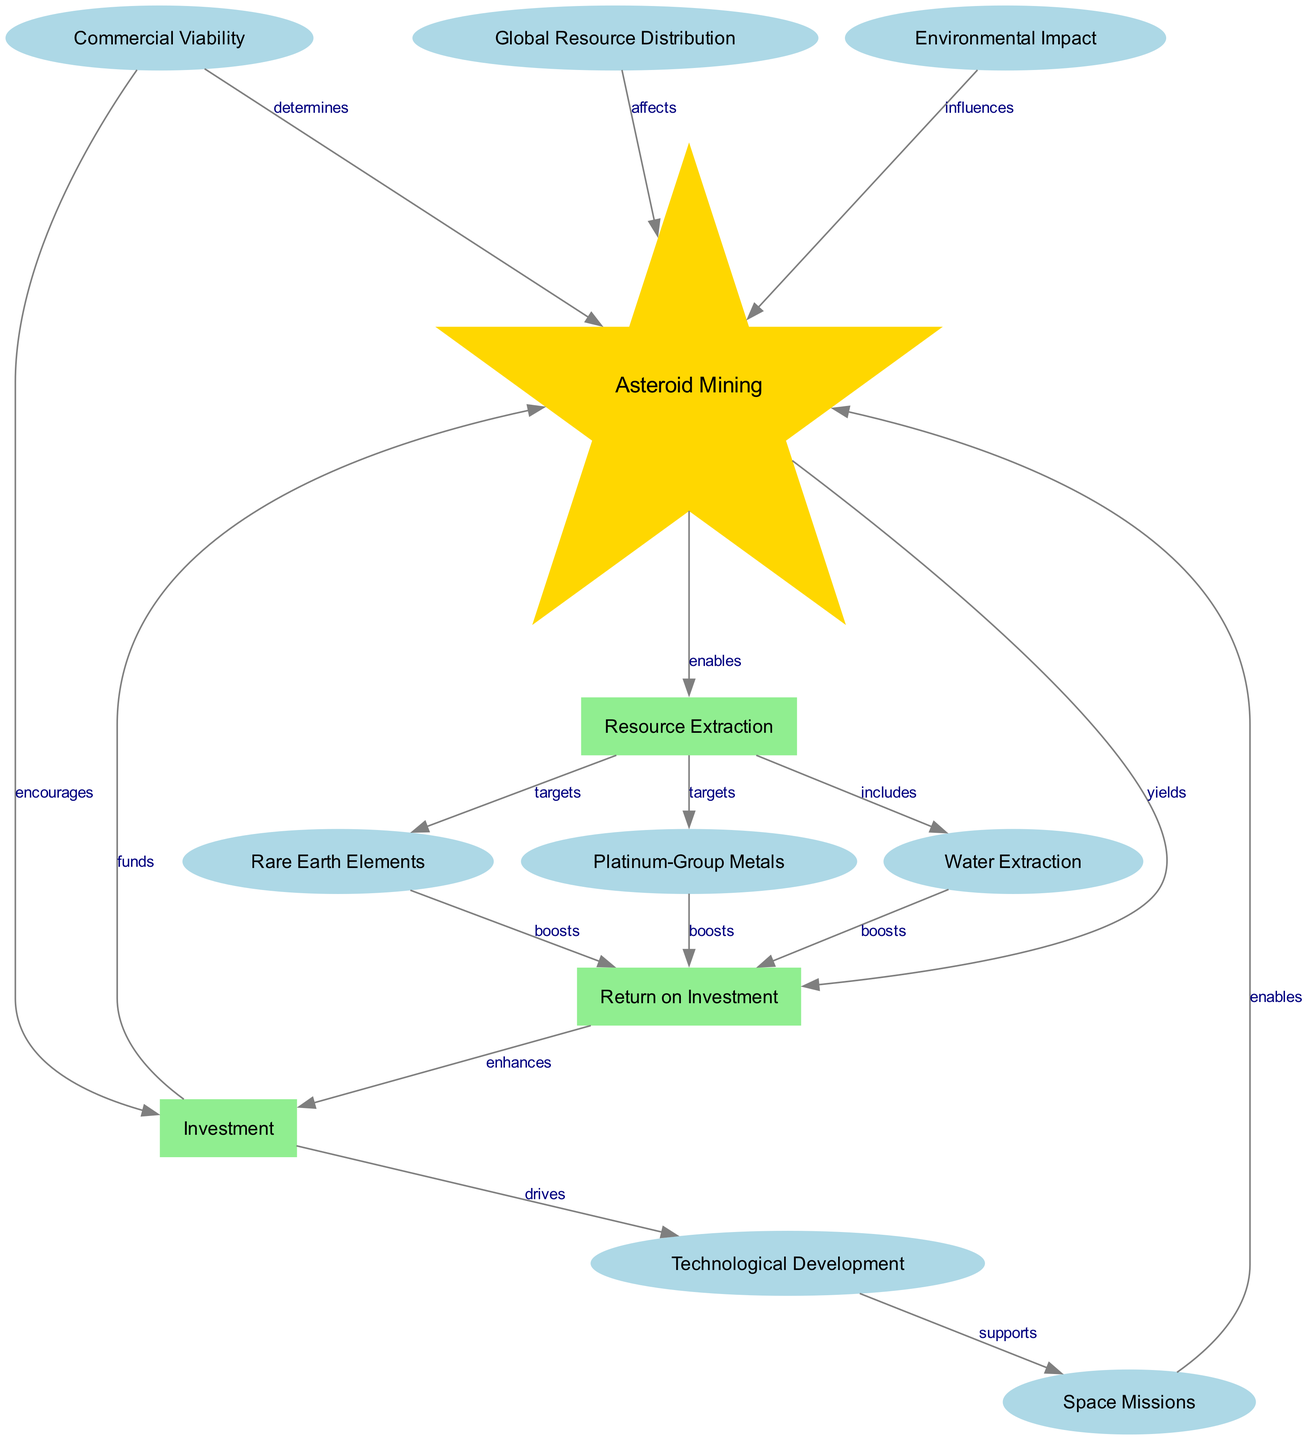What is the primary activity associated with node 1? Node 1 is labeled "Asteroid Mining," indicating that it is the central activity depicted in the diagram.
Answer: Asteroid Mining Which nodes are targeted for resource extraction? The edges from node 2 ("Resource Extraction") indicate that it targets "Platinum-Group Metals" and "Rare Earth Elements." This includes both nodes 3 and 5.
Answer: Platinum-Group Metals and Rare Earth Elements How many nodes are involved in the process of asteroid mining? The diagram contains a total of 12 nodes related to asteroid mining, including the primary node and all others, detailing various factors like resource extraction and investment.
Answer: 12 What type of relationship exists between "Investment" and "Asteroid Mining"? The edge from node 6 ("Investment") to node 1 ("Asteroid Mining") is labeled "funds," indicating a financial support relationship.
Answer: funds How does "Technological Development" support "Space Missions"? There is an edge from node 7 ("Technological Development") to node 12 ("Space Missions") that indicates it supports the latter, suggesting that advancements in technology are crucial for executing space missions.
Answer: supports What is the effect of "Global Resource Distribution" on "Asteroid Mining"? The edge from node 9 ("Global Resource Distribution") to node 1 ("Asteroid Mining") is labeled "affects," denoting that the distribution of resources globally has an impact on mining efforts.
Answer: affects How many edges originate from the "Resource Extraction" node and what are the target nodes? Three edges originate from node 2 ("Resource Extraction"), targeting nodes 3 ("Platinum-Group Metals"), 4 ("Water Extraction"), and 5 ("Rare Earth Elements").
Answer: 3; Platinum-Group Metals, Water Extraction, Rare Earth Elements What enhances the relationship between "Return on Investment" and "Investment"? The edge from node 8 ("Return on Investment") to node 6 ("Investment") is labeled "enhances," which means improvements in return benefits the investment aspect.
Answer: enhances Which factors influence "Commercial Viability"? The edge from node 11 ("Commercial Viability") to both node 1 ("Asteroid Mining") and node 6 ("Investment") indicates that commercial viability is determined by both mining and investment aspects.
Answer: Asteroid Mining and Investment 